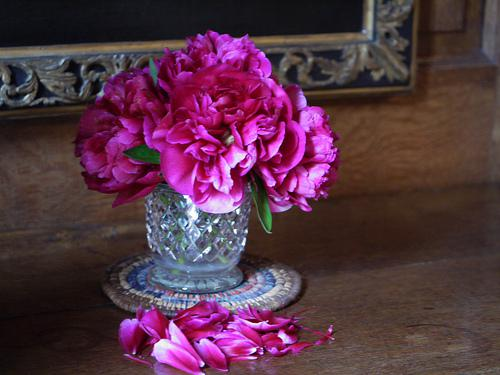Question: how did petals get on table?
Choices:
A. Flowers died.
B. Fell off flowers.
C. The flowers dried.
D. The cat knocked the flowers over.
Answer with the letter. Answer: B Question: what is this?
Choices:
A. Tulips.
B. Daisies.
C. Roses.
D. Flowers.
Answer with the letter. Answer: D Question: when was the picture taken?
Choices:
A. Afternoon.
B. Morning.
C. Lunchtime.
D. During the day.
Answer with the letter. Answer: D Question: who is in the ipicture?
Choices:
A. A woman.
B. A child.
C. A man.
D. No one.
Answer with the letter. Answer: D Question: what are the flowers in?
Choices:
A. A bowl.
B. Bucket.
C. A vase.
D. A box.
Answer with the letter. Answer: C Question: what is vase setting on?
Choices:
A. A cabinet.
B. Desk.
C. Kitchen counter.
D. A table.
Answer with the letter. Answer: D Question: why is vase setting on a coaster?
Choices:
A. To absorb water.
B. To avoid stains.
C. For decoration.
D. To stop drips.
Answer with the letter. Answer: A 